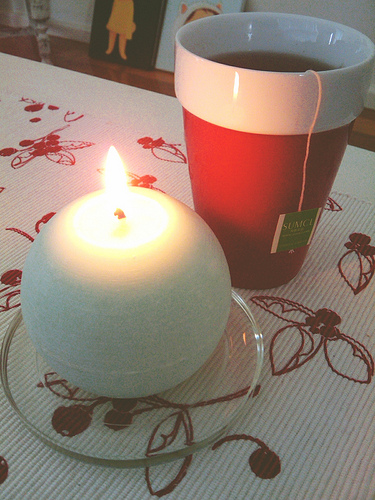<image>
Is the candle on the cup? No. The candle is not positioned on the cup. They may be near each other, but the candle is not supported by or resting on top of the cup. Is there a cup above the candle? No. The cup is not positioned above the candle. The vertical arrangement shows a different relationship. 